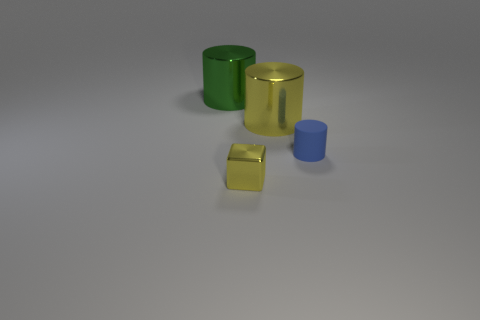Subtract all metallic cylinders. How many cylinders are left? 1 Subtract 1 cylinders. How many cylinders are left? 2 Subtract all gray balls. How many blue cylinders are left? 1 Subtract all large yellow things. Subtract all small blue rubber things. How many objects are left? 2 Add 3 small yellow cubes. How many small yellow cubes are left? 4 Add 3 metal blocks. How many metal blocks exist? 4 Add 2 large cyan rubber cylinders. How many objects exist? 6 Subtract all yellow cylinders. How many cylinders are left? 2 Subtract 0 cyan blocks. How many objects are left? 4 Subtract all cylinders. How many objects are left? 1 